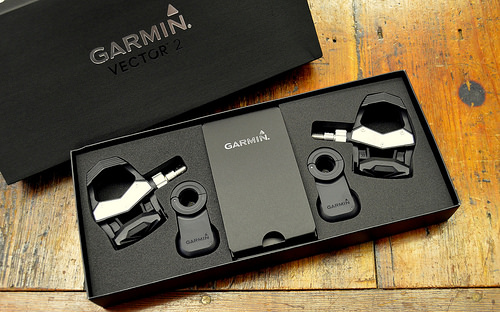<image>
Is the garmin above the vector? Yes. The garmin is positioned above the vector in the vertical space, higher up in the scene. 